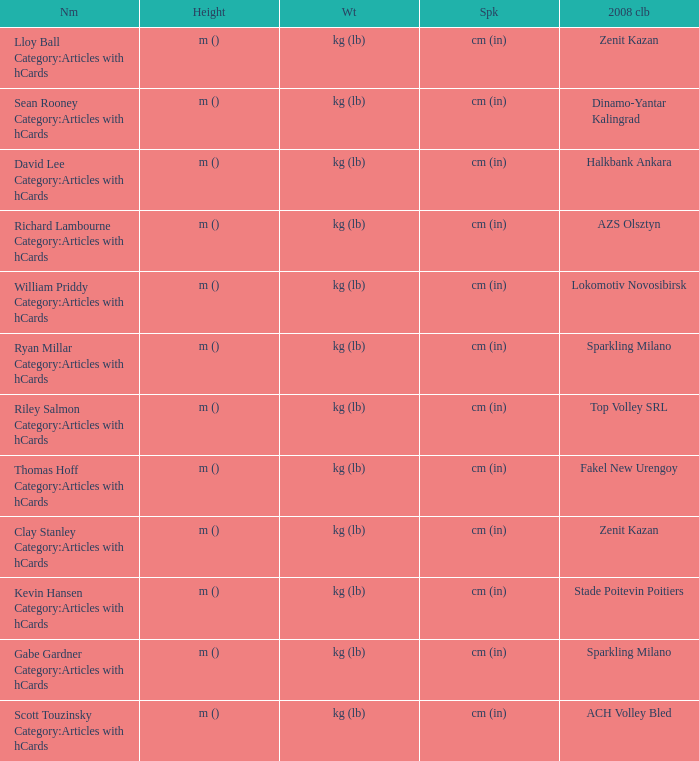What name has Fakel New Urengoy as the 2008 club? Thomas Hoff Category:Articles with hCards. 